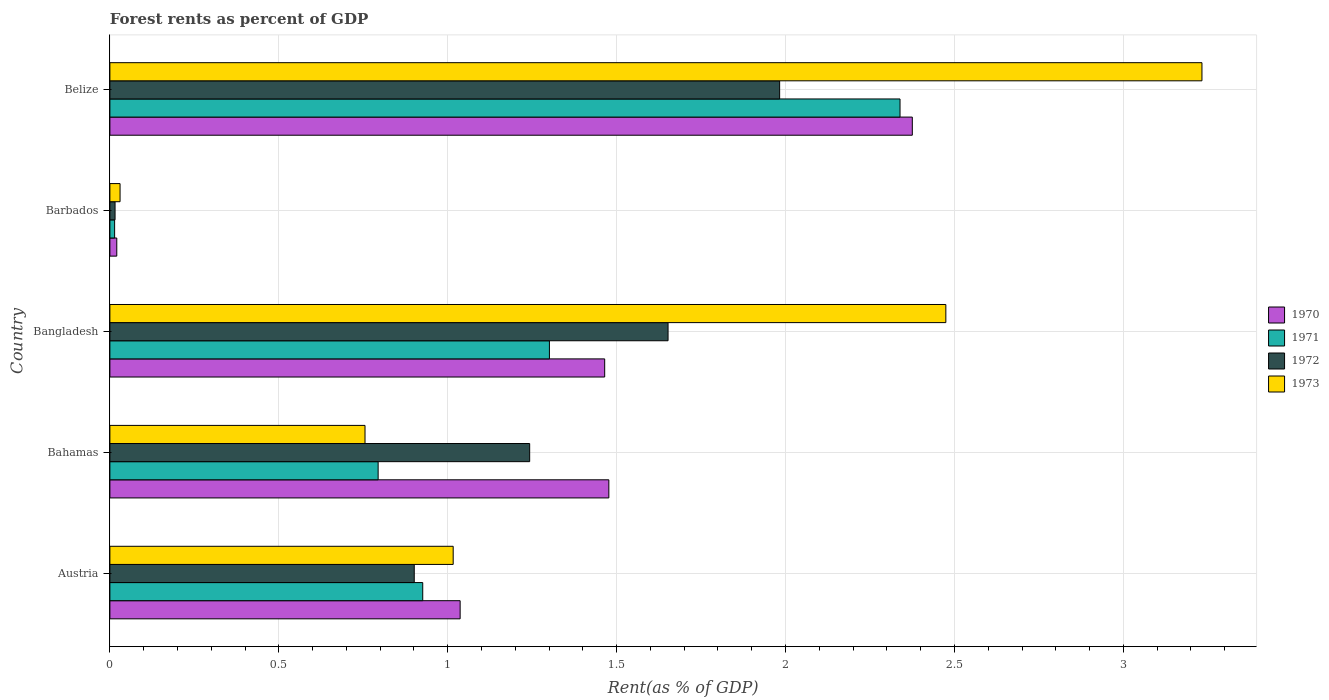How many bars are there on the 4th tick from the top?
Your answer should be very brief. 4. How many bars are there on the 2nd tick from the bottom?
Provide a succinct answer. 4. What is the label of the 1st group of bars from the top?
Ensure brevity in your answer.  Belize. In how many cases, is the number of bars for a given country not equal to the number of legend labels?
Provide a short and direct response. 0. What is the forest rent in 1970 in Belize?
Make the answer very short. 2.38. Across all countries, what is the maximum forest rent in 1972?
Provide a succinct answer. 1.98. Across all countries, what is the minimum forest rent in 1970?
Your answer should be very brief. 0.02. In which country was the forest rent in 1970 maximum?
Ensure brevity in your answer.  Belize. In which country was the forest rent in 1972 minimum?
Provide a succinct answer. Barbados. What is the total forest rent in 1970 in the graph?
Your answer should be very brief. 6.37. What is the difference between the forest rent in 1971 in Austria and that in Bangladesh?
Offer a very short reply. -0.37. What is the difference between the forest rent in 1972 in Bahamas and the forest rent in 1970 in Barbados?
Give a very brief answer. 1.22. What is the average forest rent in 1971 per country?
Make the answer very short. 1.07. What is the difference between the forest rent in 1972 and forest rent in 1970 in Barbados?
Your answer should be very brief. -0.01. What is the ratio of the forest rent in 1971 in Bangladesh to that in Barbados?
Your answer should be compact. 92.71. Is the difference between the forest rent in 1972 in Austria and Belize greater than the difference between the forest rent in 1970 in Austria and Belize?
Make the answer very short. Yes. What is the difference between the highest and the second highest forest rent in 1973?
Provide a short and direct response. 0.76. What is the difference between the highest and the lowest forest rent in 1973?
Provide a succinct answer. 3.2. In how many countries, is the forest rent in 1973 greater than the average forest rent in 1973 taken over all countries?
Your answer should be compact. 2. Is it the case that in every country, the sum of the forest rent in 1972 and forest rent in 1971 is greater than the forest rent in 1973?
Make the answer very short. No. Are all the bars in the graph horizontal?
Offer a very short reply. Yes. What is the difference between two consecutive major ticks on the X-axis?
Offer a terse response. 0.5. Are the values on the major ticks of X-axis written in scientific E-notation?
Make the answer very short. No. Does the graph contain any zero values?
Your answer should be compact. No. How are the legend labels stacked?
Offer a terse response. Vertical. What is the title of the graph?
Give a very brief answer. Forest rents as percent of GDP. Does "2008" appear as one of the legend labels in the graph?
Keep it short and to the point. No. What is the label or title of the X-axis?
Keep it short and to the point. Rent(as % of GDP). What is the label or title of the Y-axis?
Your answer should be compact. Country. What is the Rent(as % of GDP) in 1970 in Austria?
Provide a short and direct response. 1.04. What is the Rent(as % of GDP) in 1971 in Austria?
Offer a very short reply. 0.93. What is the Rent(as % of GDP) in 1972 in Austria?
Offer a very short reply. 0.9. What is the Rent(as % of GDP) in 1973 in Austria?
Offer a terse response. 1.02. What is the Rent(as % of GDP) in 1970 in Bahamas?
Your answer should be very brief. 1.48. What is the Rent(as % of GDP) of 1971 in Bahamas?
Offer a very short reply. 0.79. What is the Rent(as % of GDP) in 1972 in Bahamas?
Offer a very short reply. 1.24. What is the Rent(as % of GDP) in 1973 in Bahamas?
Your answer should be very brief. 0.76. What is the Rent(as % of GDP) of 1970 in Bangladesh?
Offer a terse response. 1.46. What is the Rent(as % of GDP) in 1971 in Bangladesh?
Offer a very short reply. 1.3. What is the Rent(as % of GDP) of 1972 in Bangladesh?
Provide a short and direct response. 1.65. What is the Rent(as % of GDP) in 1973 in Bangladesh?
Your response must be concise. 2.47. What is the Rent(as % of GDP) of 1970 in Barbados?
Your response must be concise. 0.02. What is the Rent(as % of GDP) in 1971 in Barbados?
Make the answer very short. 0.01. What is the Rent(as % of GDP) of 1972 in Barbados?
Your answer should be compact. 0.02. What is the Rent(as % of GDP) in 1973 in Barbados?
Your response must be concise. 0.03. What is the Rent(as % of GDP) of 1970 in Belize?
Your response must be concise. 2.38. What is the Rent(as % of GDP) in 1971 in Belize?
Make the answer very short. 2.34. What is the Rent(as % of GDP) in 1972 in Belize?
Make the answer very short. 1.98. What is the Rent(as % of GDP) of 1973 in Belize?
Your answer should be compact. 3.23. Across all countries, what is the maximum Rent(as % of GDP) in 1970?
Keep it short and to the point. 2.38. Across all countries, what is the maximum Rent(as % of GDP) of 1971?
Give a very brief answer. 2.34. Across all countries, what is the maximum Rent(as % of GDP) of 1972?
Ensure brevity in your answer.  1.98. Across all countries, what is the maximum Rent(as % of GDP) of 1973?
Your answer should be very brief. 3.23. Across all countries, what is the minimum Rent(as % of GDP) of 1970?
Offer a terse response. 0.02. Across all countries, what is the minimum Rent(as % of GDP) of 1971?
Ensure brevity in your answer.  0.01. Across all countries, what is the minimum Rent(as % of GDP) in 1972?
Provide a succinct answer. 0.02. Across all countries, what is the minimum Rent(as % of GDP) in 1973?
Your answer should be very brief. 0.03. What is the total Rent(as % of GDP) in 1970 in the graph?
Provide a short and direct response. 6.37. What is the total Rent(as % of GDP) of 1971 in the graph?
Your response must be concise. 5.37. What is the total Rent(as % of GDP) in 1972 in the graph?
Your answer should be very brief. 5.79. What is the total Rent(as % of GDP) of 1973 in the graph?
Offer a terse response. 7.51. What is the difference between the Rent(as % of GDP) in 1970 in Austria and that in Bahamas?
Provide a short and direct response. -0.44. What is the difference between the Rent(as % of GDP) of 1971 in Austria and that in Bahamas?
Give a very brief answer. 0.13. What is the difference between the Rent(as % of GDP) of 1972 in Austria and that in Bahamas?
Offer a very short reply. -0.34. What is the difference between the Rent(as % of GDP) in 1973 in Austria and that in Bahamas?
Provide a succinct answer. 0.26. What is the difference between the Rent(as % of GDP) of 1970 in Austria and that in Bangladesh?
Offer a very short reply. -0.43. What is the difference between the Rent(as % of GDP) in 1971 in Austria and that in Bangladesh?
Give a very brief answer. -0.38. What is the difference between the Rent(as % of GDP) of 1972 in Austria and that in Bangladesh?
Offer a terse response. -0.75. What is the difference between the Rent(as % of GDP) in 1973 in Austria and that in Bangladesh?
Offer a very short reply. -1.46. What is the difference between the Rent(as % of GDP) of 1970 in Austria and that in Barbados?
Your answer should be very brief. 1.02. What is the difference between the Rent(as % of GDP) in 1971 in Austria and that in Barbados?
Your response must be concise. 0.91. What is the difference between the Rent(as % of GDP) of 1972 in Austria and that in Barbados?
Ensure brevity in your answer.  0.89. What is the difference between the Rent(as % of GDP) of 1973 in Austria and that in Barbados?
Keep it short and to the point. 0.99. What is the difference between the Rent(as % of GDP) in 1970 in Austria and that in Belize?
Give a very brief answer. -1.34. What is the difference between the Rent(as % of GDP) in 1971 in Austria and that in Belize?
Your answer should be compact. -1.41. What is the difference between the Rent(as % of GDP) of 1972 in Austria and that in Belize?
Ensure brevity in your answer.  -1.08. What is the difference between the Rent(as % of GDP) of 1973 in Austria and that in Belize?
Your answer should be compact. -2.22. What is the difference between the Rent(as % of GDP) in 1970 in Bahamas and that in Bangladesh?
Provide a succinct answer. 0.01. What is the difference between the Rent(as % of GDP) of 1971 in Bahamas and that in Bangladesh?
Keep it short and to the point. -0.51. What is the difference between the Rent(as % of GDP) in 1972 in Bahamas and that in Bangladesh?
Make the answer very short. -0.41. What is the difference between the Rent(as % of GDP) of 1973 in Bahamas and that in Bangladesh?
Provide a succinct answer. -1.72. What is the difference between the Rent(as % of GDP) of 1970 in Bahamas and that in Barbados?
Your answer should be very brief. 1.46. What is the difference between the Rent(as % of GDP) in 1971 in Bahamas and that in Barbados?
Offer a terse response. 0.78. What is the difference between the Rent(as % of GDP) in 1972 in Bahamas and that in Barbados?
Give a very brief answer. 1.23. What is the difference between the Rent(as % of GDP) in 1973 in Bahamas and that in Barbados?
Give a very brief answer. 0.73. What is the difference between the Rent(as % of GDP) in 1970 in Bahamas and that in Belize?
Your answer should be very brief. -0.9. What is the difference between the Rent(as % of GDP) in 1971 in Bahamas and that in Belize?
Offer a terse response. -1.54. What is the difference between the Rent(as % of GDP) in 1972 in Bahamas and that in Belize?
Provide a short and direct response. -0.74. What is the difference between the Rent(as % of GDP) in 1973 in Bahamas and that in Belize?
Your response must be concise. -2.48. What is the difference between the Rent(as % of GDP) in 1970 in Bangladesh and that in Barbados?
Ensure brevity in your answer.  1.44. What is the difference between the Rent(as % of GDP) in 1971 in Bangladesh and that in Barbados?
Keep it short and to the point. 1.29. What is the difference between the Rent(as % of GDP) of 1972 in Bangladesh and that in Barbados?
Provide a short and direct response. 1.64. What is the difference between the Rent(as % of GDP) in 1973 in Bangladesh and that in Barbados?
Ensure brevity in your answer.  2.44. What is the difference between the Rent(as % of GDP) of 1970 in Bangladesh and that in Belize?
Ensure brevity in your answer.  -0.91. What is the difference between the Rent(as % of GDP) in 1971 in Bangladesh and that in Belize?
Offer a terse response. -1.04. What is the difference between the Rent(as % of GDP) in 1972 in Bangladesh and that in Belize?
Offer a very short reply. -0.33. What is the difference between the Rent(as % of GDP) of 1973 in Bangladesh and that in Belize?
Provide a succinct answer. -0.76. What is the difference between the Rent(as % of GDP) in 1970 in Barbados and that in Belize?
Your answer should be very brief. -2.35. What is the difference between the Rent(as % of GDP) of 1971 in Barbados and that in Belize?
Keep it short and to the point. -2.32. What is the difference between the Rent(as % of GDP) of 1972 in Barbados and that in Belize?
Make the answer very short. -1.97. What is the difference between the Rent(as % of GDP) in 1973 in Barbados and that in Belize?
Provide a short and direct response. -3.2. What is the difference between the Rent(as % of GDP) of 1970 in Austria and the Rent(as % of GDP) of 1971 in Bahamas?
Offer a very short reply. 0.24. What is the difference between the Rent(as % of GDP) in 1970 in Austria and the Rent(as % of GDP) in 1972 in Bahamas?
Give a very brief answer. -0.21. What is the difference between the Rent(as % of GDP) in 1970 in Austria and the Rent(as % of GDP) in 1973 in Bahamas?
Make the answer very short. 0.28. What is the difference between the Rent(as % of GDP) of 1971 in Austria and the Rent(as % of GDP) of 1972 in Bahamas?
Your response must be concise. -0.32. What is the difference between the Rent(as % of GDP) in 1971 in Austria and the Rent(as % of GDP) in 1973 in Bahamas?
Offer a very short reply. 0.17. What is the difference between the Rent(as % of GDP) in 1972 in Austria and the Rent(as % of GDP) in 1973 in Bahamas?
Give a very brief answer. 0.15. What is the difference between the Rent(as % of GDP) in 1970 in Austria and the Rent(as % of GDP) in 1971 in Bangladesh?
Make the answer very short. -0.26. What is the difference between the Rent(as % of GDP) in 1970 in Austria and the Rent(as % of GDP) in 1972 in Bangladesh?
Provide a succinct answer. -0.62. What is the difference between the Rent(as % of GDP) of 1970 in Austria and the Rent(as % of GDP) of 1973 in Bangladesh?
Your answer should be compact. -1.44. What is the difference between the Rent(as % of GDP) in 1971 in Austria and the Rent(as % of GDP) in 1972 in Bangladesh?
Make the answer very short. -0.73. What is the difference between the Rent(as % of GDP) of 1971 in Austria and the Rent(as % of GDP) of 1973 in Bangladesh?
Make the answer very short. -1.55. What is the difference between the Rent(as % of GDP) in 1972 in Austria and the Rent(as % of GDP) in 1973 in Bangladesh?
Offer a very short reply. -1.57. What is the difference between the Rent(as % of GDP) of 1970 in Austria and the Rent(as % of GDP) of 1971 in Barbados?
Ensure brevity in your answer.  1.02. What is the difference between the Rent(as % of GDP) in 1970 in Austria and the Rent(as % of GDP) in 1972 in Barbados?
Your answer should be compact. 1.02. What is the difference between the Rent(as % of GDP) in 1971 in Austria and the Rent(as % of GDP) in 1972 in Barbados?
Offer a very short reply. 0.91. What is the difference between the Rent(as % of GDP) in 1971 in Austria and the Rent(as % of GDP) in 1973 in Barbados?
Offer a very short reply. 0.9. What is the difference between the Rent(as % of GDP) in 1972 in Austria and the Rent(as % of GDP) in 1973 in Barbados?
Make the answer very short. 0.87. What is the difference between the Rent(as % of GDP) in 1970 in Austria and the Rent(as % of GDP) in 1971 in Belize?
Your response must be concise. -1.3. What is the difference between the Rent(as % of GDP) of 1970 in Austria and the Rent(as % of GDP) of 1972 in Belize?
Offer a very short reply. -0.95. What is the difference between the Rent(as % of GDP) in 1970 in Austria and the Rent(as % of GDP) in 1973 in Belize?
Your response must be concise. -2.2. What is the difference between the Rent(as % of GDP) of 1971 in Austria and the Rent(as % of GDP) of 1972 in Belize?
Offer a very short reply. -1.06. What is the difference between the Rent(as % of GDP) of 1971 in Austria and the Rent(as % of GDP) of 1973 in Belize?
Your answer should be very brief. -2.31. What is the difference between the Rent(as % of GDP) in 1972 in Austria and the Rent(as % of GDP) in 1973 in Belize?
Ensure brevity in your answer.  -2.33. What is the difference between the Rent(as % of GDP) of 1970 in Bahamas and the Rent(as % of GDP) of 1971 in Bangladesh?
Your answer should be compact. 0.18. What is the difference between the Rent(as % of GDP) in 1970 in Bahamas and the Rent(as % of GDP) in 1972 in Bangladesh?
Offer a very short reply. -0.18. What is the difference between the Rent(as % of GDP) in 1970 in Bahamas and the Rent(as % of GDP) in 1973 in Bangladesh?
Make the answer very short. -1. What is the difference between the Rent(as % of GDP) in 1971 in Bahamas and the Rent(as % of GDP) in 1972 in Bangladesh?
Your response must be concise. -0.86. What is the difference between the Rent(as % of GDP) of 1971 in Bahamas and the Rent(as % of GDP) of 1973 in Bangladesh?
Your answer should be very brief. -1.68. What is the difference between the Rent(as % of GDP) in 1972 in Bahamas and the Rent(as % of GDP) in 1973 in Bangladesh?
Give a very brief answer. -1.23. What is the difference between the Rent(as % of GDP) in 1970 in Bahamas and the Rent(as % of GDP) in 1971 in Barbados?
Offer a very short reply. 1.46. What is the difference between the Rent(as % of GDP) in 1970 in Bahamas and the Rent(as % of GDP) in 1972 in Barbados?
Ensure brevity in your answer.  1.46. What is the difference between the Rent(as % of GDP) of 1970 in Bahamas and the Rent(as % of GDP) of 1973 in Barbados?
Provide a short and direct response. 1.45. What is the difference between the Rent(as % of GDP) in 1971 in Bahamas and the Rent(as % of GDP) in 1972 in Barbados?
Your response must be concise. 0.78. What is the difference between the Rent(as % of GDP) of 1971 in Bahamas and the Rent(as % of GDP) of 1973 in Barbados?
Offer a terse response. 0.76. What is the difference between the Rent(as % of GDP) in 1972 in Bahamas and the Rent(as % of GDP) in 1973 in Barbados?
Ensure brevity in your answer.  1.21. What is the difference between the Rent(as % of GDP) in 1970 in Bahamas and the Rent(as % of GDP) in 1971 in Belize?
Provide a succinct answer. -0.86. What is the difference between the Rent(as % of GDP) in 1970 in Bahamas and the Rent(as % of GDP) in 1972 in Belize?
Provide a succinct answer. -0.51. What is the difference between the Rent(as % of GDP) in 1970 in Bahamas and the Rent(as % of GDP) in 1973 in Belize?
Make the answer very short. -1.76. What is the difference between the Rent(as % of GDP) of 1971 in Bahamas and the Rent(as % of GDP) of 1972 in Belize?
Offer a very short reply. -1.19. What is the difference between the Rent(as % of GDP) of 1971 in Bahamas and the Rent(as % of GDP) of 1973 in Belize?
Your answer should be compact. -2.44. What is the difference between the Rent(as % of GDP) in 1972 in Bahamas and the Rent(as % of GDP) in 1973 in Belize?
Offer a terse response. -1.99. What is the difference between the Rent(as % of GDP) of 1970 in Bangladesh and the Rent(as % of GDP) of 1971 in Barbados?
Give a very brief answer. 1.45. What is the difference between the Rent(as % of GDP) in 1970 in Bangladesh and the Rent(as % of GDP) in 1972 in Barbados?
Give a very brief answer. 1.45. What is the difference between the Rent(as % of GDP) in 1970 in Bangladesh and the Rent(as % of GDP) in 1973 in Barbados?
Offer a terse response. 1.43. What is the difference between the Rent(as % of GDP) of 1971 in Bangladesh and the Rent(as % of GDP) of 1972 in Barbados?
Provide a succinct answer. 1.29. What is the difference between the Rent(as % of GDP) of 1971 in Bangladesh and the Rent(as % of GDP) of 1973 in Barbados?
Provide a short and direct response. 1.27. What is the difference between the Rent(as % of GDP) of 1972 in Bangladesh and the Rent(as % of GDP) of 1973 in Barbados?
Keep it short and to the point. 1.62. What is the difference between the Rent(as % of GDP) in 1970 in Bangladesh and the Rent(as % of GDP) in 1971 in Belize?
Give a very brief answer. -0.87. What is the difference between the Rent(as % of GDP) in 1970 in Bangladesh and the Rent(as % of GDP) in 1972 in Belize?
Offer a terse response. -0.52. What is the difference between the Rent(as % of GDP) in 1970 in Bangladesh and the Rent(as % of GDP) in 1973 in Belize?
Offer a very short reply. -1.77. What is the difference between the Rent(as % of GDP) of 1971 in Bangladesh and the Rent(as % of GDP) of 1972 in Belize?
Offer a terse response. -0.68. What is the difference between the Rent(as % of GDP) of 1971 in Bangladesh and the Rent(as % of GDP) of 1973 in Belize?
Offer a terse response. -1.93. What is the difference between the Rent(as % of GDP) in 1972 in Bangladesh and the Rent(as % of GDP) in 1973 in Belize?
Offer a very short reply. -1.58. What is the difference between the Rent(as % of GDP) of 1970 in Barbados and the Rent(as % of GDP) of 1971 in Belize?
Make the answer very short. -2.32. What is the difference between the Rent(as % of GDP) of 1970 in Barbados and the Rent(as % of GDP) of 1972 in Belize?
Give a very brief answer. -1.96. What is the difference between the Rent(as % of GDP) in 1970 in Barbados and the Rent(as % of GDP) in 1973 in Belize?
Provide a short and direct response. -3.21. What is the difference between the Rent(as % of GDP) of 1971 in Barbados and the Rent(as % of GDP) of 1972 in Belize?
Make the answer very short. -1.97. What is the difference between the Rent(as % of GDP) of 1971 in Barbados and the Rent(as % of GDP) of 1973 in Belize?
Provide a short and direct response. -3.22. What is the difference between the Rent(as % of GDP) in 1972 in Barbados and the Rent(as % of GDP) in 1973 in Belize?
Provide a short and direct response. -3.22. What is the average Rent(as % of GDP) in 1970 per country?
Your response must be concise. 1.27. What is the average Rent(as % of GDP) in 1971 per country?
Give a very brief answer. 1.07. What is the average Rent(as % of GDP) of 1972 per country?
Provide a succinct answer. 1.16. What is the average Rent(as % of GDP) in 1973 per country?
Make the answer very short. 1.5. What is the difference between the Rent(as % of GDP) of 1970 and Rent(as % of GDP) of 1971 in Austria?
Provide a succinct answer. 0.11. What is the difference between the Rent(as % of GDP) of 1970 and Rent(as % of GDP) of 1972 in Austria?
Give a very brief answer. 0.14. What is the difference between the Rent(as % of GDP) in 1970 and Rent(as % of GDP) in 1973 in Austria?
Ensure brevity in your answer.  0.02. What is the difference between the Rent(as % of GDP) of 1971 and Rent(as % of GDP) of 1972 in Austria?
Keep it short and to the point. 0.03. What is the difference between the Rent(as % of GDP) in 1971 and Rent(as % of GDP) in 1973 in Austria?
Your answer should be compact. -0.09. What is the difference between the Rent(as % of GDP) in 1972 and Rent(as % of GDP) in 1973 in Austria?
Give a very brief answer. -0.12. What is the difference between the Rent(as % of GDP) of 1970 and Rent(as % of GDP) of 1971 in Bahamas?
Make the answer very short. 0.68. What is the difference between the Rent(as % of GDP) of 1970 and Rent(as % of GDP) of 1972 in Bahamas?
Keep it short and to the point. 0.23. What is the difference between the Rent(as % of GDP) in 1970 and Rent(as % of GDP) in 1973 in Bahamas?
Your response must be concise. 0.72. What is the difference between the Rent(as % of GDP) in 1971 and Rent(as % of GDP) in 1972 in Bahamas?
Make the answer very short. -0.45. What is the difference between the Rent(as % of GDP) of 1971 and Rent(as % of GDP) of 1973 in Bahamas?
Provide a succinct answer. 0.04. What is the difference between the Rent(as % of GDP) of 1972 and Rent(as % of GDP) of 1973 in Bahamas?
Provide a short and direct response. 0.49. What is the difference between the Rent(as % of GDP) of 1970 and Rent(as % of GDP) of 1971 in Bangladesh?
Give a very brief answer. 0.16. What is the difference between the Rent(as % of GDP) in 1970 and Rent(as % of GDP) in 1972 in Bangladesh?
Provide a short and direct response. -0.19. What is the difference between the Rent(as % of GDP) in 1970 and Rent(as % of GDP) in 1973 in Bangladesh?
Your answer should be compact. -1.01. What is the difference between the Rent(as % of GDP) of 1971 and Rent(as % of GDP) of 1972 in Bangladesh?
Keep it short and to the point. -0.35. What is the difference between the Rent(as % of GDP) of 1971 and Rent(as % of GDP) of 1973 in Bangladesh?
Give a very brief answer. -1.17. What is the difference between the Rent(as % of GDP) in 1972 and Rent(as % of GDP) in 1973 in Bangladesh?
Your response must be concise. -0.82. What is the difference between the Rent(as % of GDP) of 1970 and Rent(as % of GDP) of 1971 in Barbados?
Offer a terse response. 0.01. What is the difference between the Rent(as % of GDP) of 1970 and Rent(as % of GDP) of 1972 in Barbados?
Offer a terse response. 0.01. What is the difference between the Rent(as % of GDP) of 1970 and Rent(as % of GDP) of 1973 in Barbados?
Offer a terse response. -0.01. What is the difference between the Rent(as % of GDP) in 1971 and Rent(as % of GDP) in 1972 in Barbados?
Your answer should be compact. -0. What is the difference between the Rent(as % of GDP) in 1971 and Rent(as % of GDP) in 1973 in Barbados?
Your response must be concise. -0.02. What is the difference between the Rent(as % of GDP) of 1972 and Rent(as % of GDP) of 1973 in Barbados?
Give a very brief answer. -0.01. What is the difference between the Rent(as % of GDP) in 1970 and Rent(as % of GDP) in 1971 in Belize?
Ensure brevity in your answer.  0.04. What is the difference between the Rent(as % of GDP) in 1970 and Rent(as % of GDP) in 1972 in Belize?
Make the answer very short. 0.39. What is the difference between the Rent(as % of GDP) of 1970 and Rent(as % of GDP) of 1973 in Belize?
Offer a very short reply. -0.86. What is the difference between the Rent(as % of GDP) in 1971 and Rent(as % of GDP) in 1972 in Belize?
Offer a very short reply. 0.36. What is the difference between the Rent(as % of GDP) of 1971 and Rent(as % of GDP) of 1973 in Belize?
Your response must be concise. -0.89. What is the difference between the Rent(as % of GDP) in 1972 and Rent(as % of GDP) in 1973 in Belize?
Make the answer very short. -1.25. What is the ratio of the Rent(as % of GDP) of 1970 in Austria to that in Bahamas?
Offer a terse response. 0.7. What is the ratio of the Rent(as % of GDP) in 1971 in Austria to that in Bahamas?
Your answer should be compact. 1.17. What is the ratio of the Rent(as % of GDP) of 1972 in Austria to that in Bahamas?
Your answer should be very brief. 0.72. What is the ratio of the Rent(as % of GDP) of 1973 in Austria to that in Bahamas?
Your answer should be compact. 1.35. What is the ratio of the Rent(as % of GDP) in 1970 in Austria to that in Bangladesh?
Provide a short and direct response. 0.71. What is the ratio of the Rent(as % of GDP) in 1971 in Austria to that in Bangladesh?
Your response must be concise. 0.71. What is the ratio of the Rent(as % of GDP) in 1972 in Austria to that in Bangladesh?
Keep it short and to the point. 0.55. What is the ratio of the Rent(as % of GDP) in 1973 in Austria to that in Bangladesh?
Ensure brevity in your answer.  0.41. What is the ratio of the Rent(as % of GDP) of 1970 in Austria to that in Barbados?
Your answer should be compact. 50.82. What is the ratio of the Rent(as % of GDP) of 1971 in Austria to that in Barbados?
Provide a short and direct response. 65.99. What is the ratio of the Rent(as % of GDP) in 1972 in Austria to that in Barbados?
Give a very brief answer. 58.93. What is the ratio of the Rent(as % of GDP) of 1973 in Austria to that in Barbados?
Make the answer very short. 33.75. What is the ratio of the Rent(as % of GDP) of 1970 in Austria to that in Belize?
Your answer should be compact. 0.44. What is the ratio of the Rent(as % of GDP) in 1971 in Austria to that in Belize?
Your response must be concise. 0.4. What is the ratio of the Rent(as % of GDP) in 1972 in Austria to that in Belize?
Provide a short and direct response. 0.45. What is the ratio of the Rent(as % of GDP) in 1973 in Austria to that in Belize?
Your response must be concise. 0.31. What is the ratio of the Rent(as % of GDP) of 1970 in Bahamas to that in Bangladesh?
Keep it short and to the point. 1.01. What is the ratio of the Rent(as % of GDP) in 1971 in Bahamas to that in Bangladesh?
Provide a succinct answer. 0.61. What is the ratio of the Rent(as % of GDP) of 1972 in Bahamas to that in Bangladesh?
Your answer should be compact. 0.75. What is the ratio of the Rent(as % of GDP) in 1973 in Bahamas to that in Bangladesh?
Your response must be concise. 0.31. What is the ratio of the Rent(as % of GDP) in 1970 in Bahamas to that in Barbados?
Your answer should be compact. 72.4. What is the ratio of the Rent(as % of GDP) of 1971 in Bahamas to that in Barbados?
Make the answer very short. 56.58. What is the ratio of the Rent(as % of GDP) of 1972 in Bahamas to that in Barbados?
Your response must be concise. 81.28. What is the ratio of the Rent(as % of GDP) of 1973 in Bahamas to that in Barbados?
Your answer should be compact. 25.08. What is the ratio of the Rent(as % of GDP) of 1970 in Bahamas to that in Belize?
Your response must be concise. 0.62. What is the ratio of the Rent(as % of GDP) of 1971 in Bahamas to that in Belize?
Offer a very short reply. 0.34. What is the ratio of the Rent(as % of GDP) of 1972 in Bahamas to that in Belize?
Your answer should be very brief. 0.63. What is the ratio of the Rent(as % of GDP) of 1973 in Bahamas to that in Belize?
Offer a very short reply. 0.23. What is the ratio of the Rent(as % of GDP) in 1970 in Bangladesh to that in Barbados?
Make the answer very short. 71.79. What is the ratio of the Rent(as % of GDP) in 1971 in Bangladesh to that in Barbados?
Provide a short and direct response. 92.71. What is the ratio of the Rent(as % of GDP) in 1972 in Bangladesh to that in Barbados?
Make the answer very short. 108.07. What is the ratio of the Rent(as % of GDP) in 1973 in Bangladesh to that in Barbados?
Your answer should be very brief. 82.18. What is the ratio of the Rent(as % of GDP) of 1970 in Bangladesh to that in Belize?
Keep it short and to the point. 0.62. What is the ratio of the Rent(as % of GDP) in 1971 in Bangladesh to that in Belize?
Provide a short and direct response. 0.56. What is the ratio of the Rent(as % of GDP) in 1972 in Bangladesh to that in Belize?
Your response must be concise. 0.83. What is the ratio of the Rent(as % of GDP) in 1973 in Bangladesh to that in Belize?
Ensure brevity in your answer.  0.77. What is the ratio of the Rent(as % of GDP) in 1970 in Barbados to that in Belize?
Your response must be concise. 0.01. What is the ratio of the Rent(as % of GDP) in 1971 in Barbados to that in Belize?
Your answer should be very brief. 0.01. What is the ratio of the Rent(as % of GDP) of 1972 in Barbados to that in Belize?
Offer a terse response. 0.01. What is the ratio of the Rent(as % of GDP) of 1973 in Barbados to that in Belize?
Make the answer very short. 0.01. What is the difference between the highest and the second highest Rent(as % of GDP) in 1970?
Offer a very short reply. 0.9. What is the difference between the highest and the second highest Rent(as % of GDP) of 1971?
Provide a short and direct response. 1.04. What is the difference between the highest and the second highest Rent(as % of GDP) in 1972?
Your answer should be very brief. 0.33. What is the difference between the highest and the second highest Rent(as % of GDP) of 1973?
Offer a terse response. 0.76. What is the difference between the highest and the lowest Rent(as % of GDP) in 1970?
Provide a succinct answer. 2.35. What is the difference between the highest and the lowest Rent(as % of GDP) of 1971?
Offer a terse response. 2.32. What is the difference between the highest and the lowest Rent(as % of GDP) of 1972?
Your response must be concise. 1.97. What is the difference between the highest and the lowest Rent(as % of GDP) of 1973?
Make the answer very short. 3.2. 